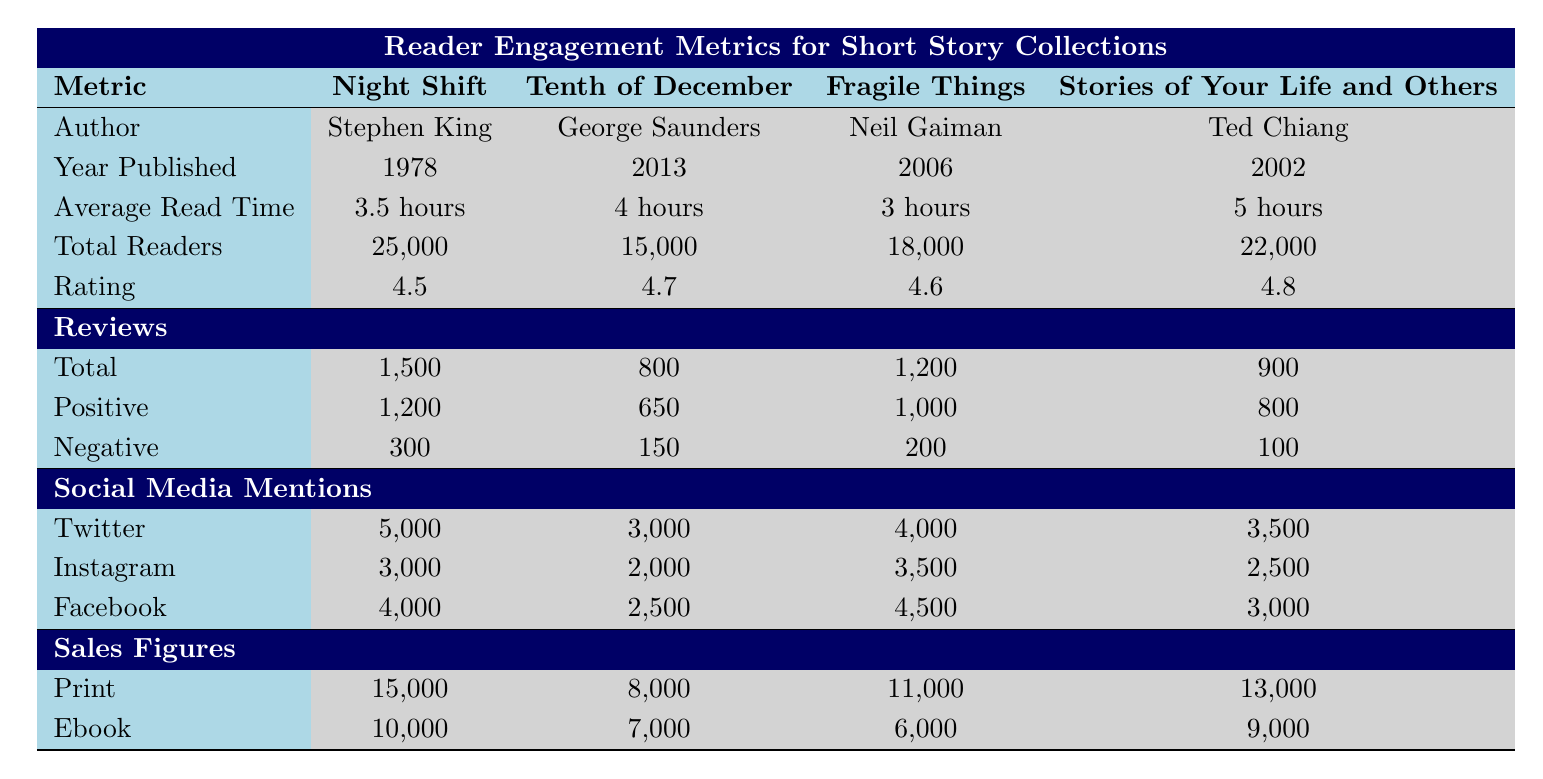What is the average read time for "Fragile Things"? The average read time for a book is given in the table under the "Average Read Time" column. For "Fragile Things," it is specified as 3 hours.
Answer: 3 hours Which collection has the highest rating? To determine which collection has the highest rating, I will look for the maximum value in the "Rating" column. "Stories of Your Life and Others" has a rating of 4.8, which is the highest among the collections.
Answer: Stories of Your Life and Others How many total reviews were made for "Tenth of December"? The total reviews for "Tenth of December" are listed in the "Reviews" section under "Total." It shows a total of 800 reviews.
Answer: 800 What is the combined total of print sales for both "Night Shift" and "Fragile Things"? The print sales for "Night Shift" are 15,000, and for "Fragile Things" it is 11,000. Adding these two figures together gives 15,000 + 11,000 = 26,000.
Answer: 26,000 Is the average read time for "Stories of Your Life and Others" longer than that of "Tenth of December"? The average read time for "Stories of Your Life and Others" is 5 hours while "Tenth of December" is 4 hours. Since 5 is greater than 4, the statement is true.
Answer: Yes How many more readers does "Night Shift" have compared to "Tenth of December"? "Night Shift" has 25,000 readers, while "Tenth of December" has 15,000. To find the difference, subtract 15,000 from 25,000, which gives 25,000 - 15,000 = 10,000.
Answer: 10,000 Which author has the most social media mentions on Facebook? To find out which author has the most mentions on Facebook, I look at the "Social Media Mentions" section under the "Facebook" row. "Fragile Things" has 4,500 mentions, which is more than others.
Answer: Neil Gaiman How many negative reviews did "Stories of Your Life and Others" receive? The "Negative" reviews for "Stories of Your Life and Others" are specifically mentioned in the "Reviews" section, showing a total of 100 negative reviews.
Answer: 100 What is the total number of Positive reviews across all collections? To find the total positive reviews, I sum the positive reviews from each collection: 1,200 (Night Shift) + 650 (Tenth of December) + 1,000 (Fragile Things) + 800 (Stories of Your Life and Others) equals 3,650.
Answer: 3,650 